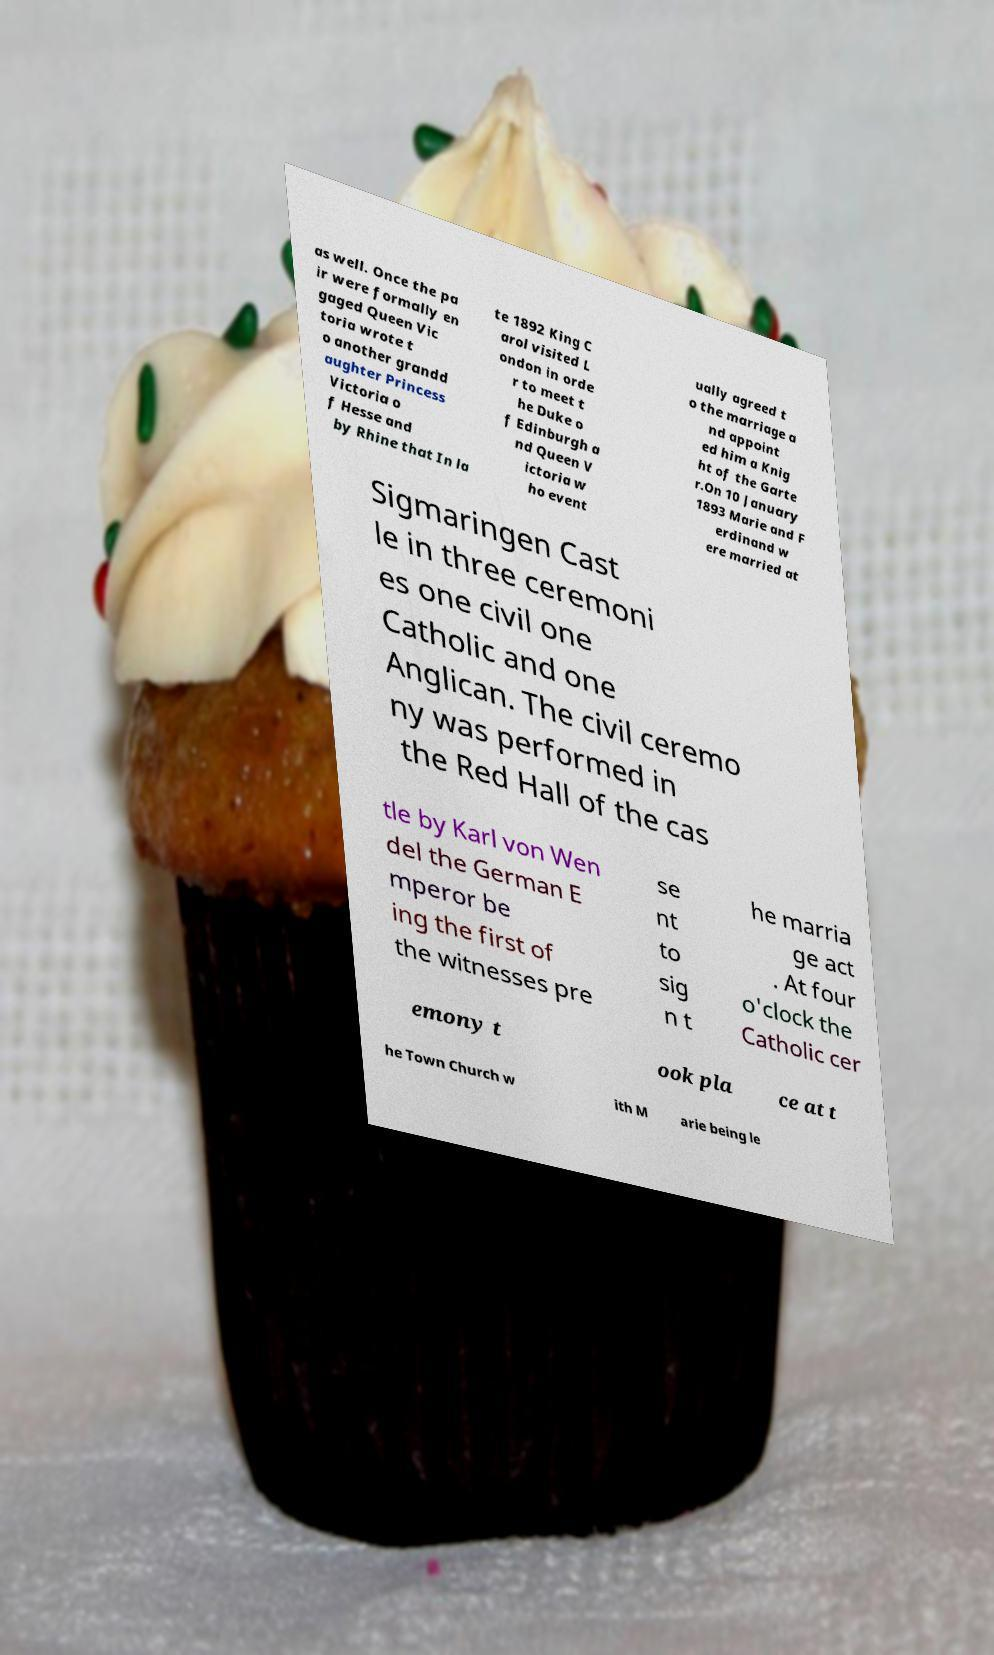For documentation purposes, I need the text within this image transcribed. Could you provide that? as well. Once the pa ir were formally en gaged Queen Vic toria wrote t o another grandd aughter Princess Victoria o f Hesse and by Rhine that In la te 1892 King C arol visited L ondon in orde r to meet t he Duke o f Edinburgh a nd Queen V ictoria w ho event ually agreed t o the marriage a nd appoint ed him a Knig ht of the Garte r.On 10 January 1893 Marie and F erdinand w ere married at Sigmaringen Cast le in three ceremoni es one civil one Catholic and one Anglican. The civil ceremo ny was performed in the Red Hall of the cas tle by Karl von Wen del the German E mperor be ing the first of the witnesses pre se nt to sig n t he marria ge act . At four o'clock the Catholic cer emony t ook pla ce at t he Town Church w ith M arie being le 